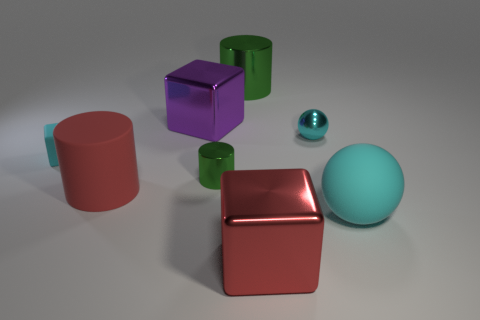Add 2 big cyan rubber balls. How many objects exist? 10 Subtract all cylinders. How many objects are left? 5 Subtract 1 cyan balls. How many objects are left? 7 Subtract all purple cubes. Subtract all cylinders. How many objects are left? 4 Add 7 large matte cylinders. How many large matte cylinders are left? 8 Add 2 tiny cyan shiny blocks. How many tiny cyan shiny blocks exist? 2 